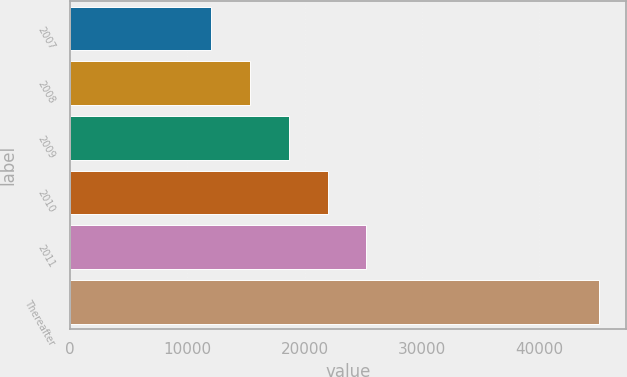<chart> <loc_0><loc_0><loc_500><loc_500><bar_chart><fcel>2007<fcel>2008<fcel>2009<fcel>2010<fcel>2011<fcel>Thereafter<nl><fcel>12030<fcel>15338.3<fcel>18646.6<fcel>21954.9<fcel>25263.2<fcel>45113<nl></chart> 